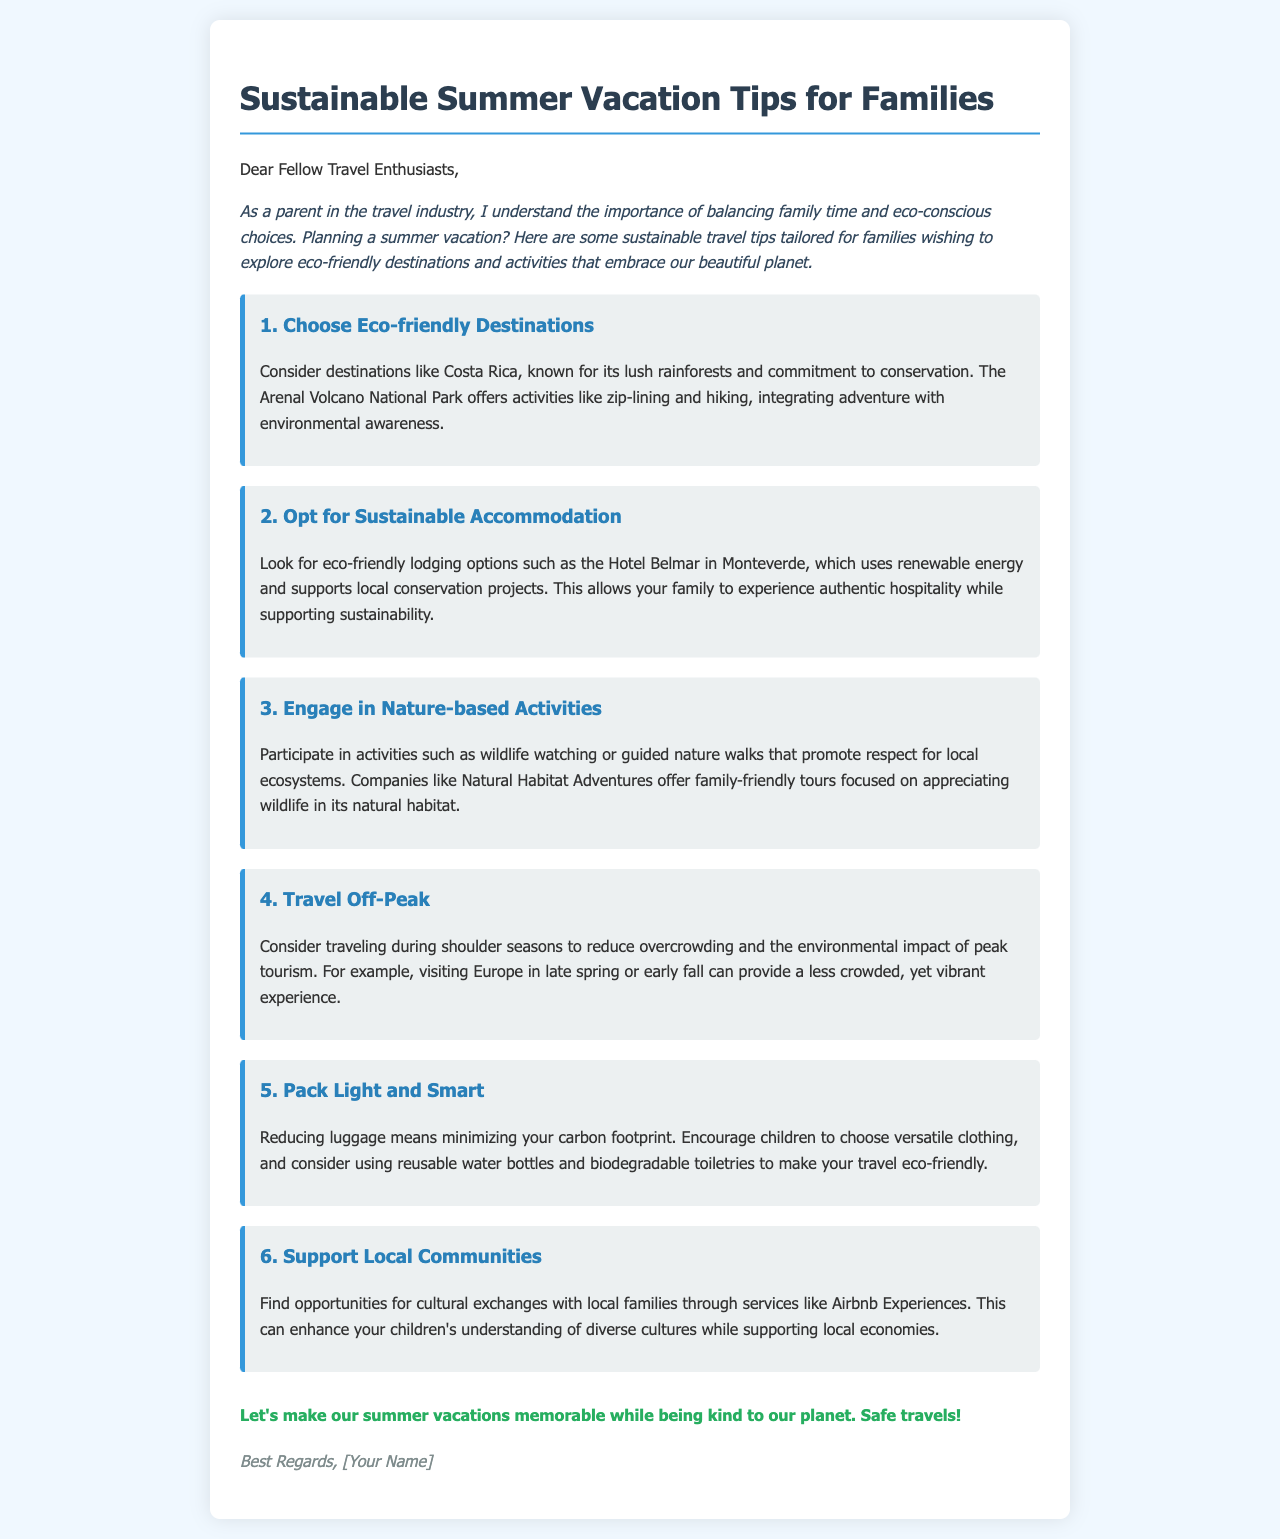What is one eco-friendly destination mentioned? The email highlights Costa Rica as an eco-friendly destination known for its conservation efforts.
Answer: Costa Rica What type of accommodation is recommended? The document suggests looking for eco-friendly lodging options, such as those using renewable energy.
Answer: Sustainable accommodation What activity is offered at Arenal Volcano National Park? The document mentions zip-lining and hiking as activities available at this park, integrating adventure with environmental awareness.
Answer: Zip-lining What is a reason for traveling off-peak? The email states that traveling during shoulder seasons can reduce overcrowding and the environmental impact of peak tourism.
Answer: Reduce overcrowding Which organization offers family-friendly wildlife tours? The email mentions Natural Habitat Adventures as a company that provides such tours focused on wildlife appreciation.
Answer: Natural Habitat Adventures What is one tip for packing? The document advises to encourage children to choose versatile clothing to help reduce luggage.
Answer: Pack light What can families support when using Airbnb Experiences? The email points out that families can enhance their children's understanding of diverse cultures while supporting local economies.
Answer: Local economies What is the primary goal of the email? The email emphasizes making summer vacations memorable while being environmentally conscious.
Answer: Kind to our planet 